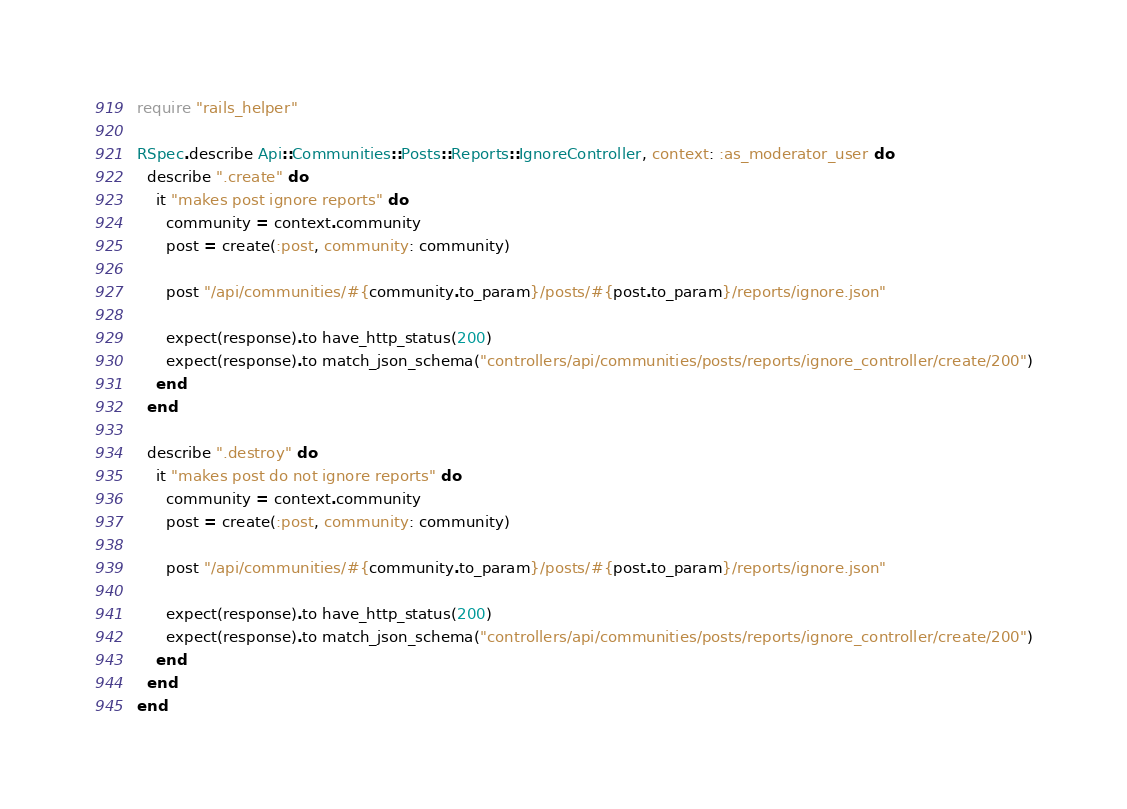<code> <loc_0><loc_0><loc_500><loc_500><_Ruby_>require "rails_helper"

RSpec.describe Api::Communities::Posts::Reports::IgnoreController, context: :as_moderator_user do
  describe ".create" do
    it "makes post ignore reports" do
      community = context.community
      post = create(:post, community: community)

      post "/api/communities/#{community.to_param}/posts/#{post.to_param}/reports/ignore.json"

      expect(response).to have_http_status(200)
      expect(response).to match_json_schema("controllers/api/communities/posts/reports/ignore_controller/create/200")
    end
  end

  describe ".destroy" do
    it "makes post do not ignore reports" do
      community = context.community
      post = create(:post, community: community)

      post "/api/communities/#{community.to_param}/posts/#{post.to_param}/reports/ignore.json"

      expect(response).to have_http_status(200)
      expect(response).to match_json_schema("controllers/api/communities/posts/reports/ignore_controller/create/200")
    end
  end
end
</code> 